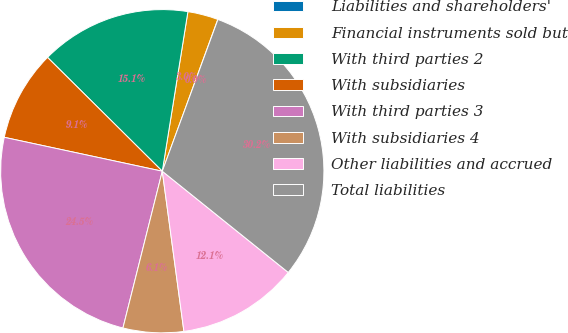Convert chart to OTSL. <chart><loc_0><loc_0><loc_500><loc_500><pie_chart><fcel>Liabilities and shareholders'<fcel>Financial instruments sold but<fcel>With third parties 2<fcel>With subsidiaries<fcel>With third parties 3<fcel>With subsidiaries 4<fcel>Other liabilities and accrued<fcel>Total liabilities<nl><fcel>0.02%<fcel>3.04%<fcel>15.1%<fcel>9.07%<fcel>24.45%<fcel>6.05%<fcel>12.09%<fcel>30.18%<nl></chart> 